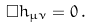<formula> <loc_0><loc_0><loc_500><loc_500>\Box h _ { \mu \nu } = 0 \, .</formula> 